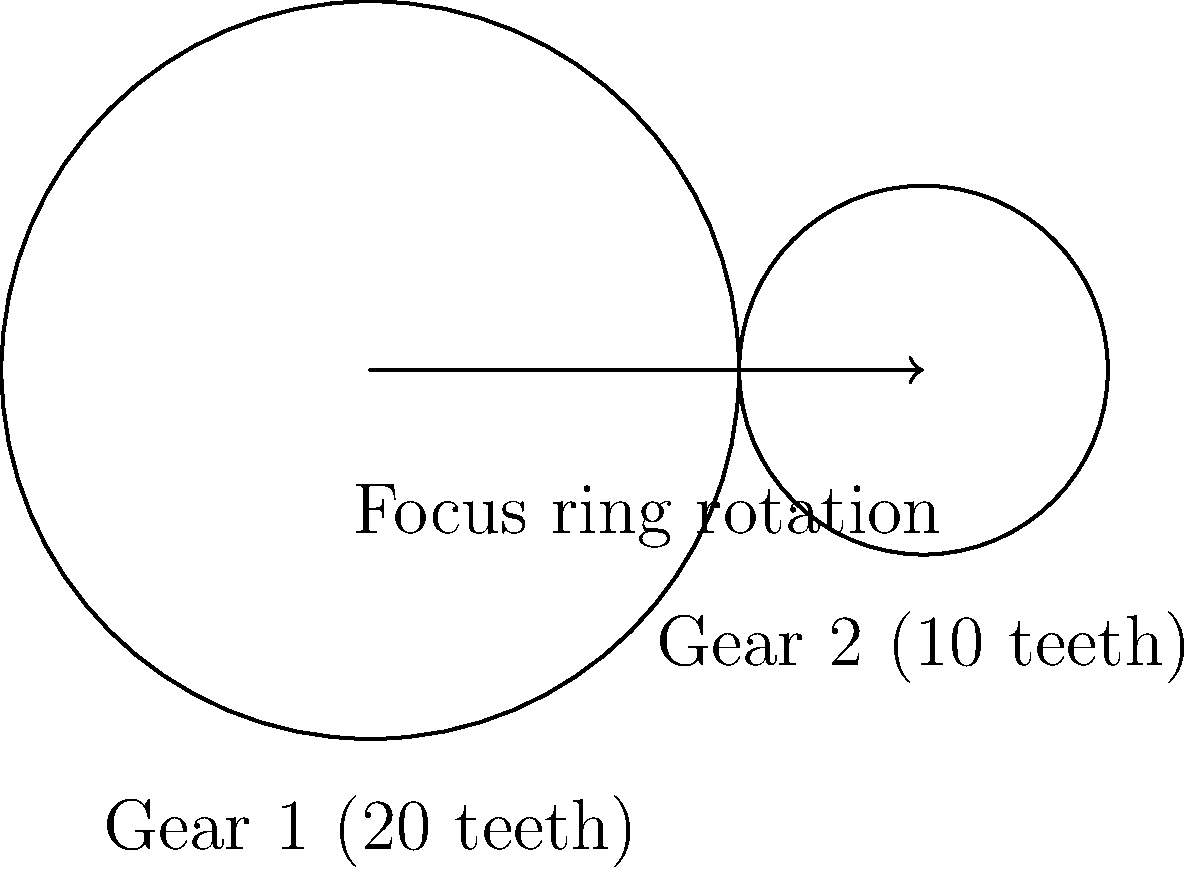In a manual focus camera lens, the focus ring is connected to Gear 1, which meshes with Gear 2 to move the lens elements. If Gear 1 has 20 teeth and Gear 2 has 10 teeth, what is the gear ratio, and how many degrees does Gear 2 rotate when the focus ring (Gear 1) is turned 90 degrees? To solve this problem, we need to follow these steps:

1. Calculate the gear ratio:
   The gear ratio is defined as the number of teeth on the driven gear (Gear 2) divided by the number of teeth on the driving gear (Gear 1).
   
   Gear ratio = $\frac{\text{Teeth on Gear 2}}{\text{Teeth on Gear 1}} = \frac{10}{20} = \frac{1}{2}$

2. Determine the relationship between the rotations of Gear 1 and Gear 2:
   The gear ratio tells us that for every full rotation of Gear 1, Gear 2 will rotate twice.

3. Calculate the rotation of Gear 2 when Gear 1 rotates 90 degrees:
   If Gear 1 rotates 90 degrees (1/4 of a full rotation), Gear 2 will rotate twice as much.
   
   Rotation of Gear 2 = $90° \times 2 = 180°$

Therefore, when the focus ring (Gear 1) is turned 90 degrees, Gear 2 will rotate 180 degrees.
Answer: Gear ratio: 1:2; Gear 2 rotation: 180° 